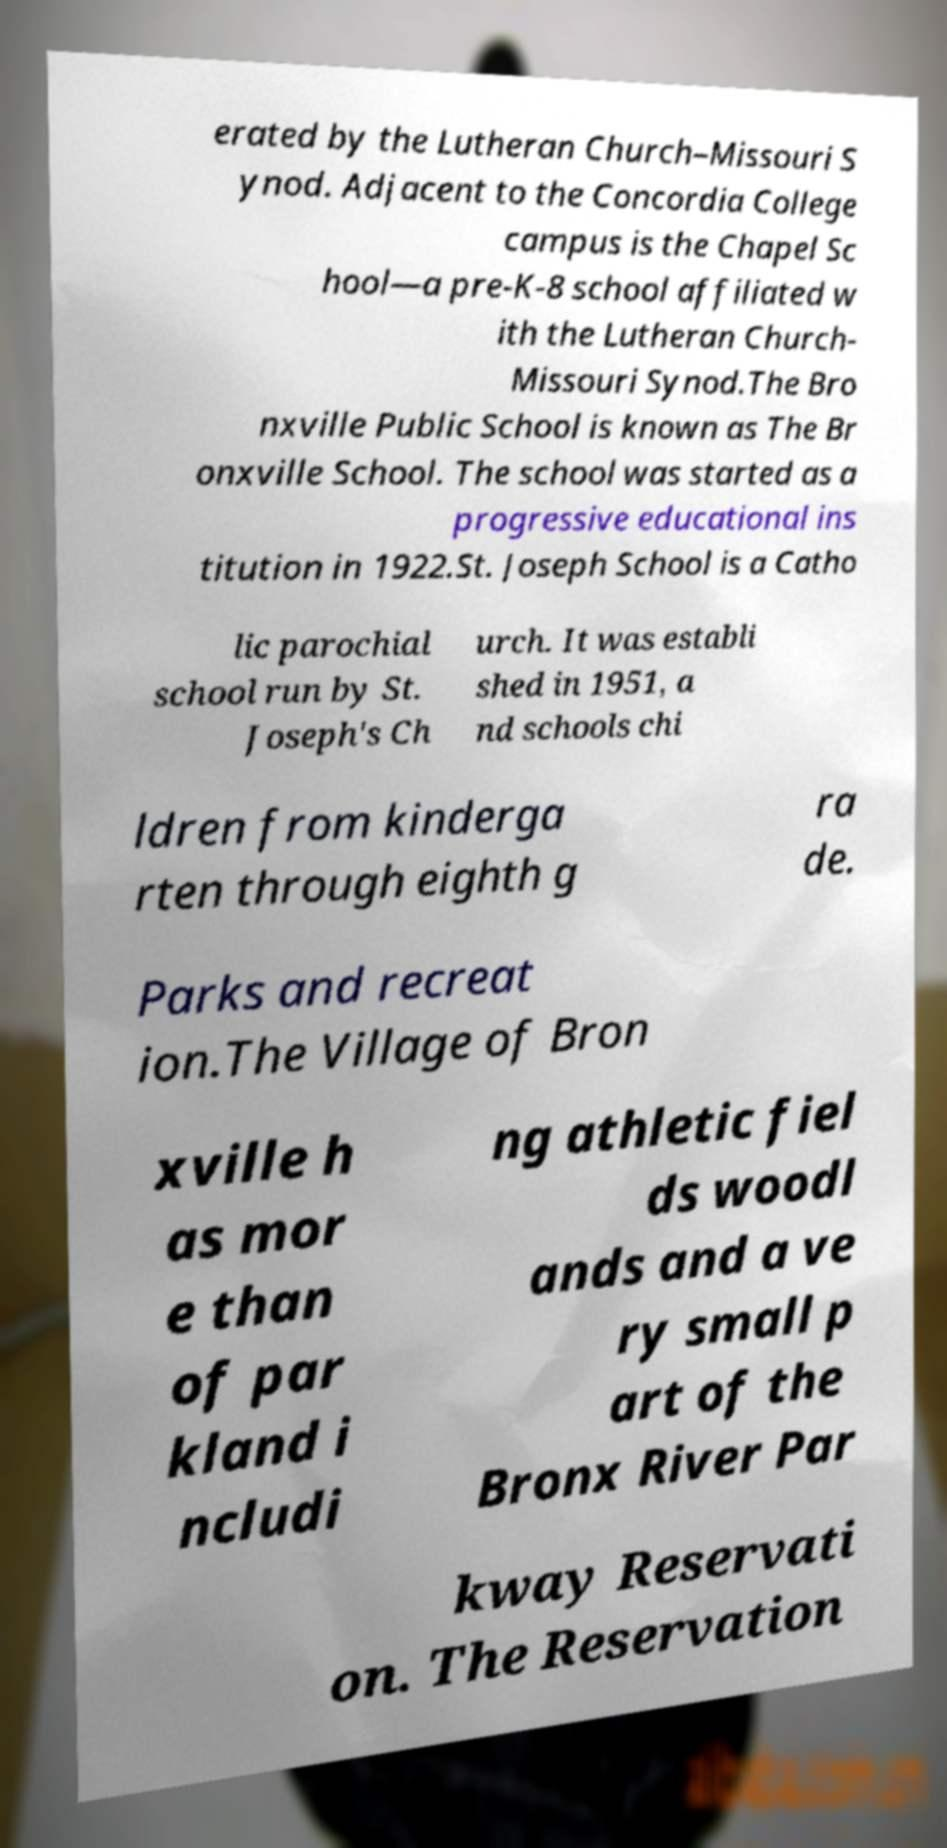There's text embedded in this image that I need extracted. Can you transcribe it verbatim? erated by the Lutheran Church–Missouri S ynod. Adjacent to the Concordia College campus is the Chapel Sc hool—a pre-K-8 school affiliated w ith the Lutheran Church- Missouri Synod.The Bro nxville Public School is known as The Br onxville School. The school was started as a progressive educational ins titution in 1922.St. Joseph School is a Catho lic parochial school run by St. Joseph's Ch urch. It was establi shed in 1951, a nd schools chi ldren from kinderga rten through eighth g ra de. Parks and recreat ion.The Village of Bron xville h as mor e than of par kland i ncludi ng athletic fiel ds woodl ands and a ve ry small p art of the Bronx River Par kway Reservati on. The Reservation 